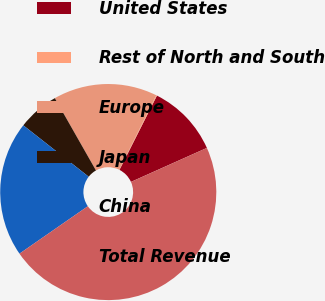Convert chart. <chart><loc_0><loc_0><loc_500><loc_500><pie_chart><fcel>United States<fcel>Rest of North and South<fcel>Europe<fcel>Japan<fcel>China<fcel>Total Revenue<nl><fcel>10.86%<fcel>0.11%<fcel>15.56%<fcel>6.17%<fcel>20.25%<fcel>47.04%<nl></chart> 